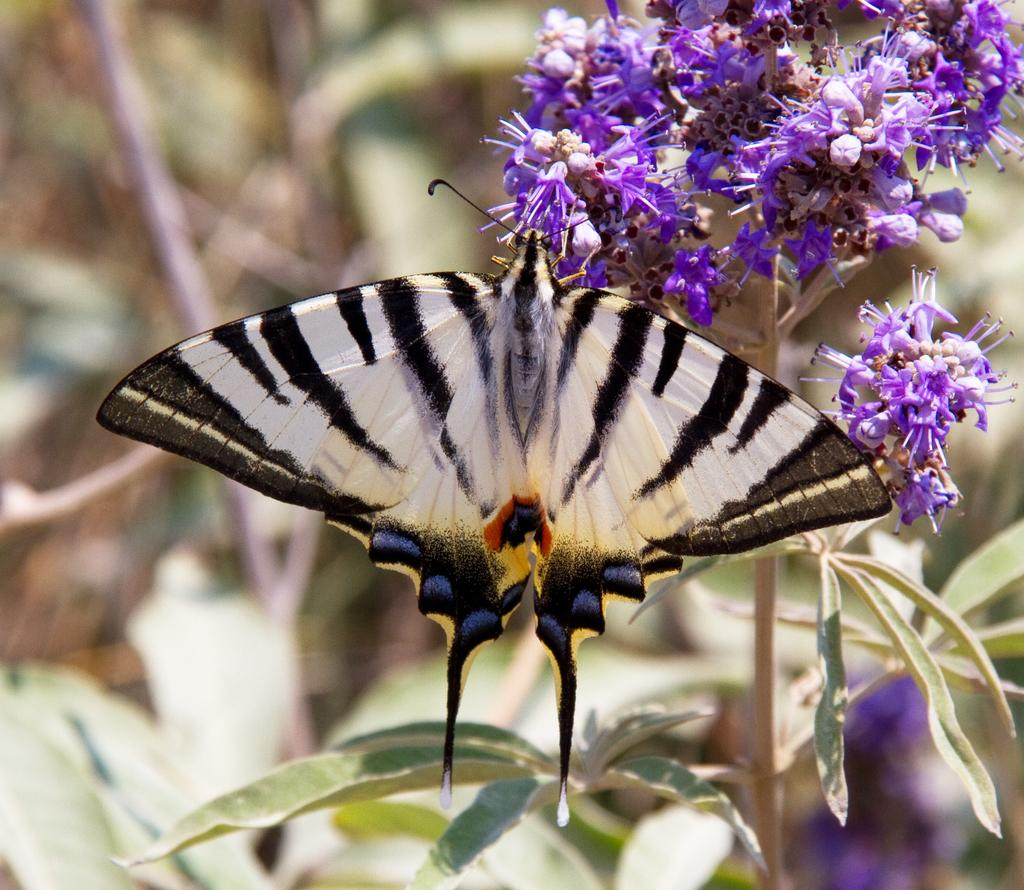What is the main subject of the image? There is a butterfly in the image. Where is the butterfly located in the image? The butterfly is on flowers. Can you describe the background of the image? The background of the image is blurry. How does the butterfly talk to the flowers in the image? Butterflies do not have the ability to talk, and there is no indication in the image that they are communicating with the flowers. 